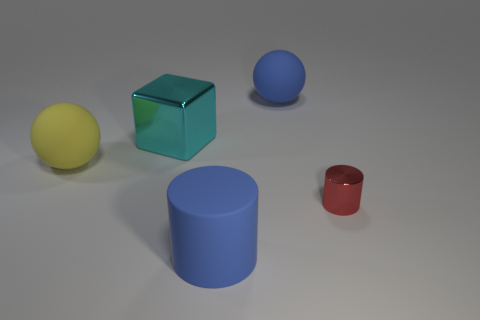Are there any other things that have the same color as the large cylinder?
Give a very brief answer. Yes. The big object that is the same color as the big cylinder is what shape?
Provide a short and direct response. Sphere. There is a big cylinder; is its color the same as the big matte thing that is right of the blue cylinder?
Offer a terse response. Yes. Are there any big matte objects of the same color as the rubber cylinder?
Offer a terse response. Yes. Is the red cylinder made of the same material as the blue object that is in front of the large yellow matte thing?
Offer a very short reply. No. Is there a tiny object that has the same material as the big cylinder?
Your answer should be very brief. No. How many objects are either spheres in front of the big blue matte sphere or things that are behind the yellow matte thing?
Keep it short and to the point. 3. Do the small object and the large blue object in front of the yellow ball have the same shape?
Your answer should be very brief. Yes. How many other things are there of the same shape as the big shiny thing?
Your answer should be very brief. 0. What number of objects are green matte blocks or blue spheres?
Ensure brevity in your answer.  1. 